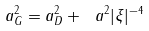Convert formula to latex. <formula><loc_0><loc_0><loc_500><loc_500>a ^ { 2 } _ { G } = a _ { D } ^ { 2 } + \ a ^ { 2 } | \xi | ^ { - 4 }</formula> 